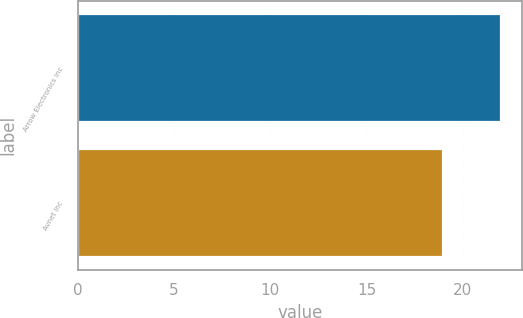Convert chart to OTSL. <chart><loc_0><loc_0><loc_500><loc_500><bar_chart><fcel>Arrow Electronics Inc<fcel>Avnet Inc<nl><fcel>22<fcel>19<nl></chart> 